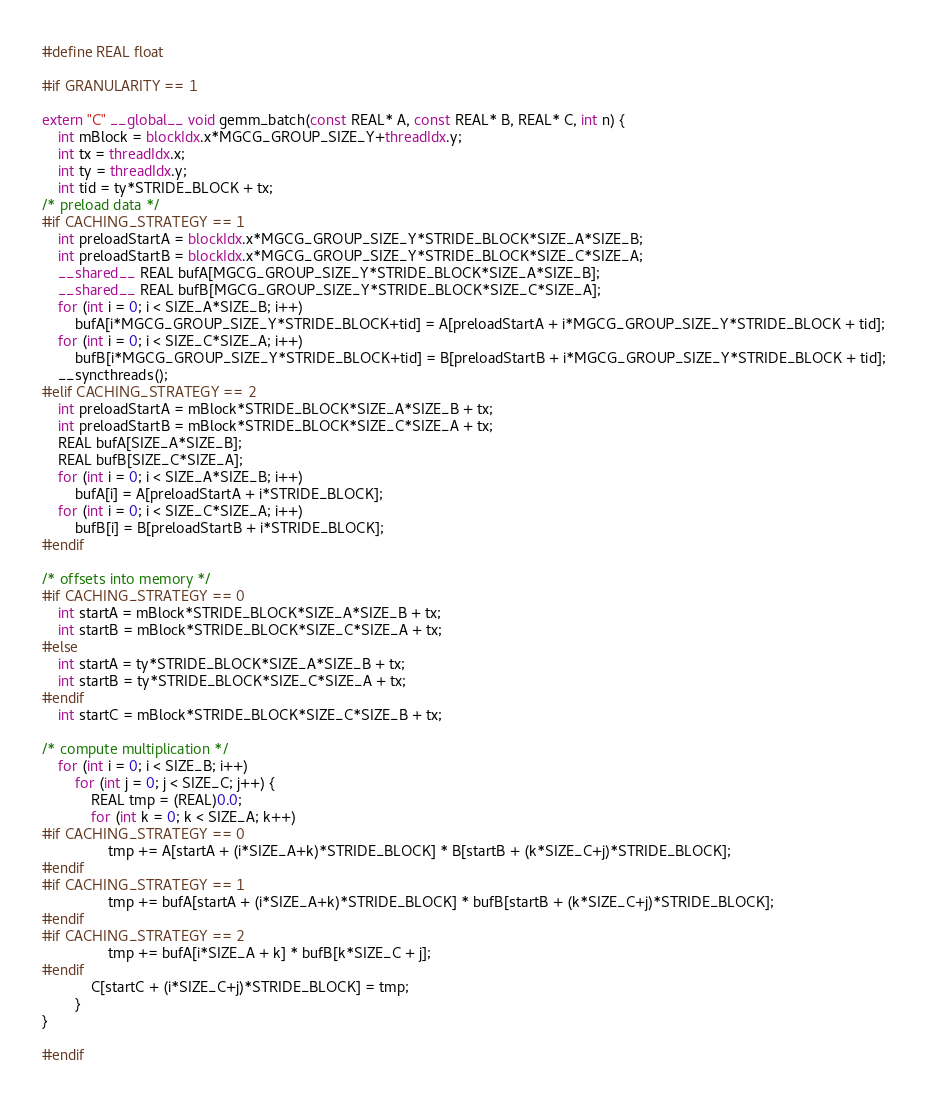<code> <loc_0><loc_0><loc_500><loc_500><_Cuda_>#define REAL float

#if GRANULARITY == 1

extern "C" __global__ void gemm_batch(const REAL* A, const REAL* B, REAL* C, int n) {
	int mBlock = blockIdx.x*MGCG_GROUP_SIZE_Y+threadIdx.y;
	int tx = threadIdx.x;
    int ty = threadIdx.y;
    int tid = ty*STRIDE_BLOCK + tx;
/* preload data */
#if CACHING_STRATEGY == 1
    int preloadStartA = blockIdx.x*MGCG_GROUP_SIZE_Y*STRIDE_BLOCK*SIZE_A*SIZE_B;
    int preloadStartB = blockIdx.x*MGCG_GROUP_SIZE_Y*STRIDE_BLOCK*SIZE_C*SIZE_A;
	__shared__ REAL bufA[MGCG_GROUP_SIZE_Y*STRIDE_BLOCK*SIZE_A*SIZE_B];
	__shared__ REAL bufB[MGCG_GROUP_SIZE_Y*STRIDE_BLOCK*SIZE_C*SIZE_A];
	for (int i = 0; i < SIZE_A*SIZE_B; i++)
		bufA[i*MGCG_GROUP_SIZE_Y*STRIDE_BLOCK+tid] = A[preloadStartA + i*MGCG_GROUP_SIZE_Y*STRIDE_BLOCK + tid];
	for (int i = 0; i < SIZE_C*SIZE_A; i++)
        bufB[i*MGCG_GROUP_SIZE_Y*STRIDE_BLOCK+tid] = B[preloadStartB + i*MGCG_GROUP_SIZE_Y*STRIDE_BLOCK + tid];
	__syncthreads();
#elif CACHING_STRATEGY == 2
    int preloadStartA = mBlock*STRIDE_BLOCK*SIZE_A*SIZE_B + tx;
    int preloadStartB = mBlock*STRIDE_BLOCK*SIZE_C*SIZE_A + tx;
    REAL bufA[SIZE_A*SIZE_B];
    REAL bufB[SIZE_C*SIZE_A];
    for (int i = 0; i < SIZE_A*SIZE_B; i++)
        bufA[i] = A[preloadStartA + i*STRIDE_BLOCK];
    for (int i = 0; i < SIZE_C*SIZE_A; i++)
        bufB[i] = B[preloadStartB + i*STRIDE_BLOCK];
#endif

/* offsets into memory */
#if CACHING_STRATEGY == 0
    int startA = mBlock*STRIDE_BLOCK*SIZE_A*SIZE_B + tx;
    int startB = mBlock*STRIDE_BLOCK*SIZE_C*SIZE_A + tx;
#else
    int startA = ty*STRIDE_BLOCK*SIZE_A*SIZE_B + tx;
    int startB = ty*STRIDE_BLOCK*SIZE_C*SIZE_A + tx;
#endif
    int startC = mBlock*STRIDE_BLOCK*SIZE_C*SIZE_B + tx;

/* compute multiplication */
    for (int i = 0; i < SIZE_B; i++)
        for (int j = 0; j < SIZE_C; j++) {
            REAL tmp = (REAL)0.0;
            for (int k = 0; k < SIZE_A; k++)
#if CACHING_STRATEGY == 0
                tmp += A[startA + (i*SIZE_A+k)*STRIDE_BLOCK] * B[startB + (k*SIZE_C+j)*STRIDE_BLOCK];
#endif
#if CACHING_STRATEGY == 1
                tmp += bufA[startA + (i*SIZE_A+k)*STRIDE_BLOCK] * bufB[startB + (k*SIZE_C+j)*STRIDE_BLOCK];
#endif
#if CACHING_STRATEGY == 2
                tmp += bufA[i*SIZE_A + k] * bufB[k*SIZE_C + j];
#endif
            C[startC + (i*SIZE_C+j)*STRIDE_BLOCK] = tmp;
        }
}

#endif

</code> 